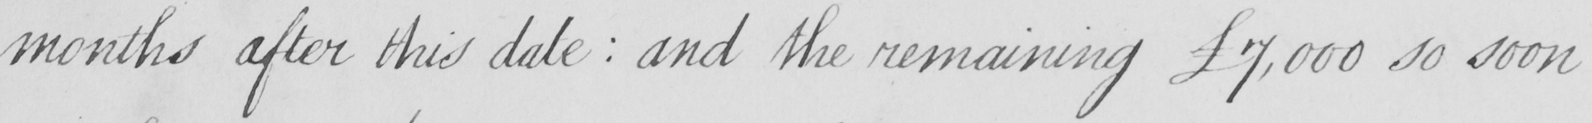Please provide the text content of this handwritten line. months after this date  :  and the remaining £7,000 so soon 